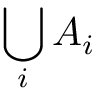Convert formula to latex. <formula><loc_0><loc_0><loc_500><loc_500>\bigcup _ { i } A _ { i }</formula> 